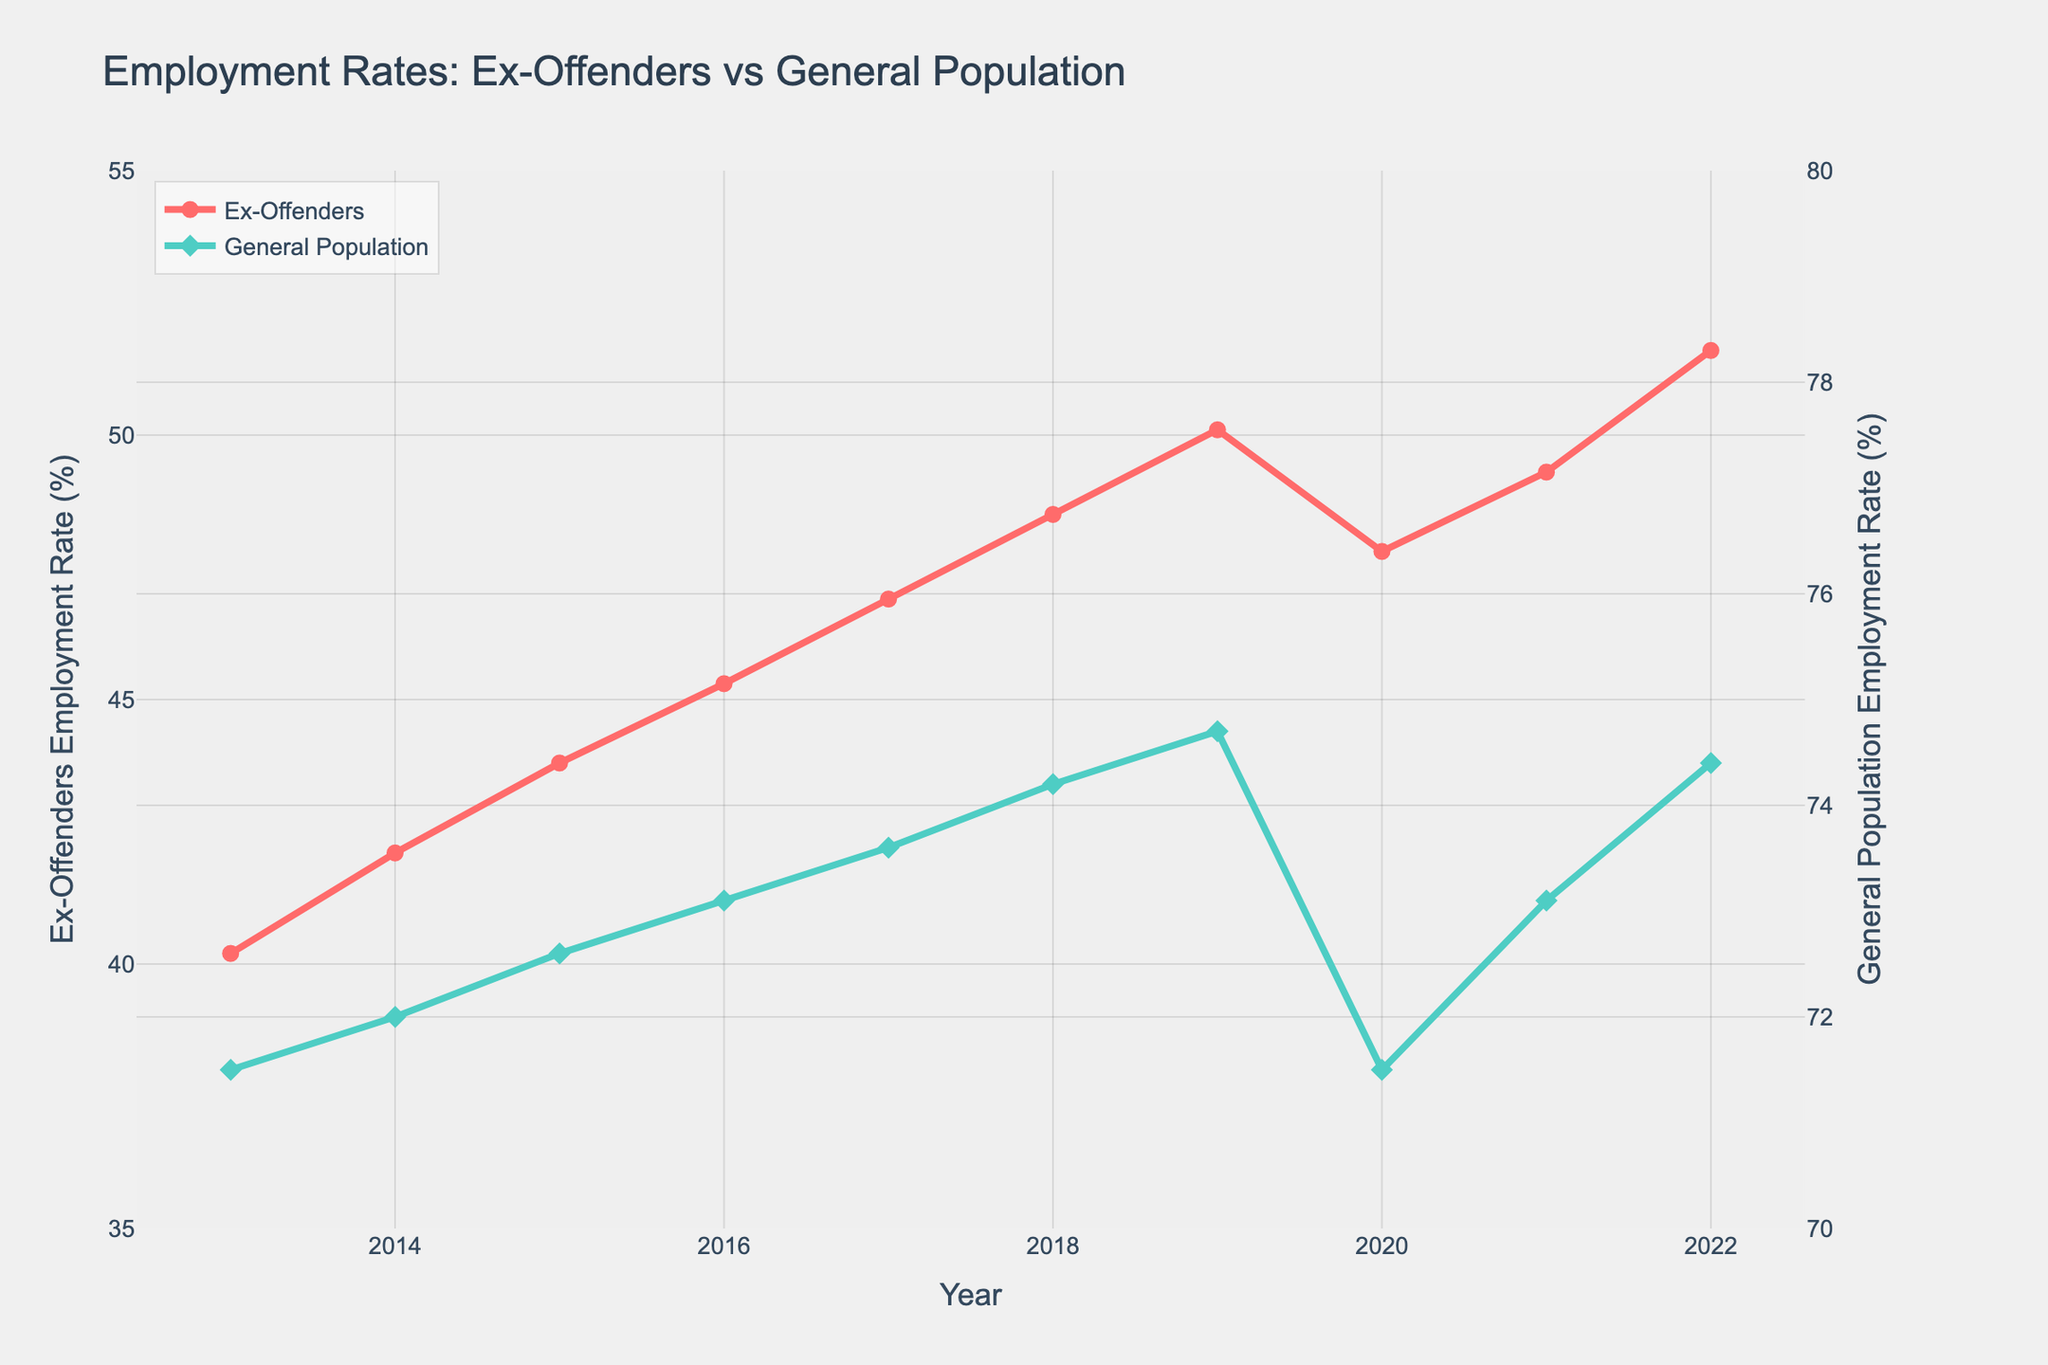What trend can be observed for the employment rate of ex-offenders over the 10-year period? The employment rate of ex-offenders shows a general increasing trend from 40.2% in 2013 to 51.6% in 2022, except for a slight dip in 2020.
Answer: Increasing trend with a dip in 2020 How does the employment rate of ex-offenders compare to that of the general population in 2022? In 2022, the employment rate of ex-offenders is 51.6% while that of the general population is 74.4%.
Answer: Ex-offenders: 51.6%, General Population: 74.4% What is the difference in the employment rate between ex-offenders and the general population in 2020? The employment rate of ex-offenders in 2020 is 47.8%, and for the general population, it is 71.5%. The difference is 71.5% - 47.8%.
Answer: 23.7% What is the average employment rate of ex-offenders over the 10-year period? The sum of the employment rates from 2013 to 2022 is 465.6%. The average is 465.6% / 10.
Answer: 46.56% By how much did the employment rate of ex-offenders increase from 2013 to 2019? In 2013, the rate was 40.2%, and in 2019, it was 50.1%. The increase is 50.1% - 40.2%.
Answer: 9.9% What was the lowest employment rate for the general population during the 10-year period, and in which year did it occur? The lowest employment rate for the general population was 71.5% in the years 2013 and 2020.
Answer: 71.5% in 2013 and 2020 In which year did the employment rate of ex-offenders grow the most compared to the previous year? The largest increase occurred between 2018 and 2019, where the rate went from 48.5% to 50.1%, an increase of 50.1% - 48.5%.
Answer: 2019 Compare the trend lines of ex-offenders and the general population. Are the trends similar or different? Both trend lines show an overall increase over the 10-year period but the general population has smaller and more consistent increments, while ex-offenders show more variation and a notable dip in 2020.
Answer: Similar but with more variation for ex-offenders What is the total increase in the employment rate of the general population from 2013 to 2022? The general population employment rate goes from 71.5% in 2013 to 74.4% in 2022. The total increase is 74.4% - 71.5%.
Answer: 2.9% Between which consecutive years did the general population employment rate see the greatest increase? From 2017 to 2018, the rate increased from 73.6% to 74.2%, an increase of 74.2% - 73.6%.
Answer: 2018 